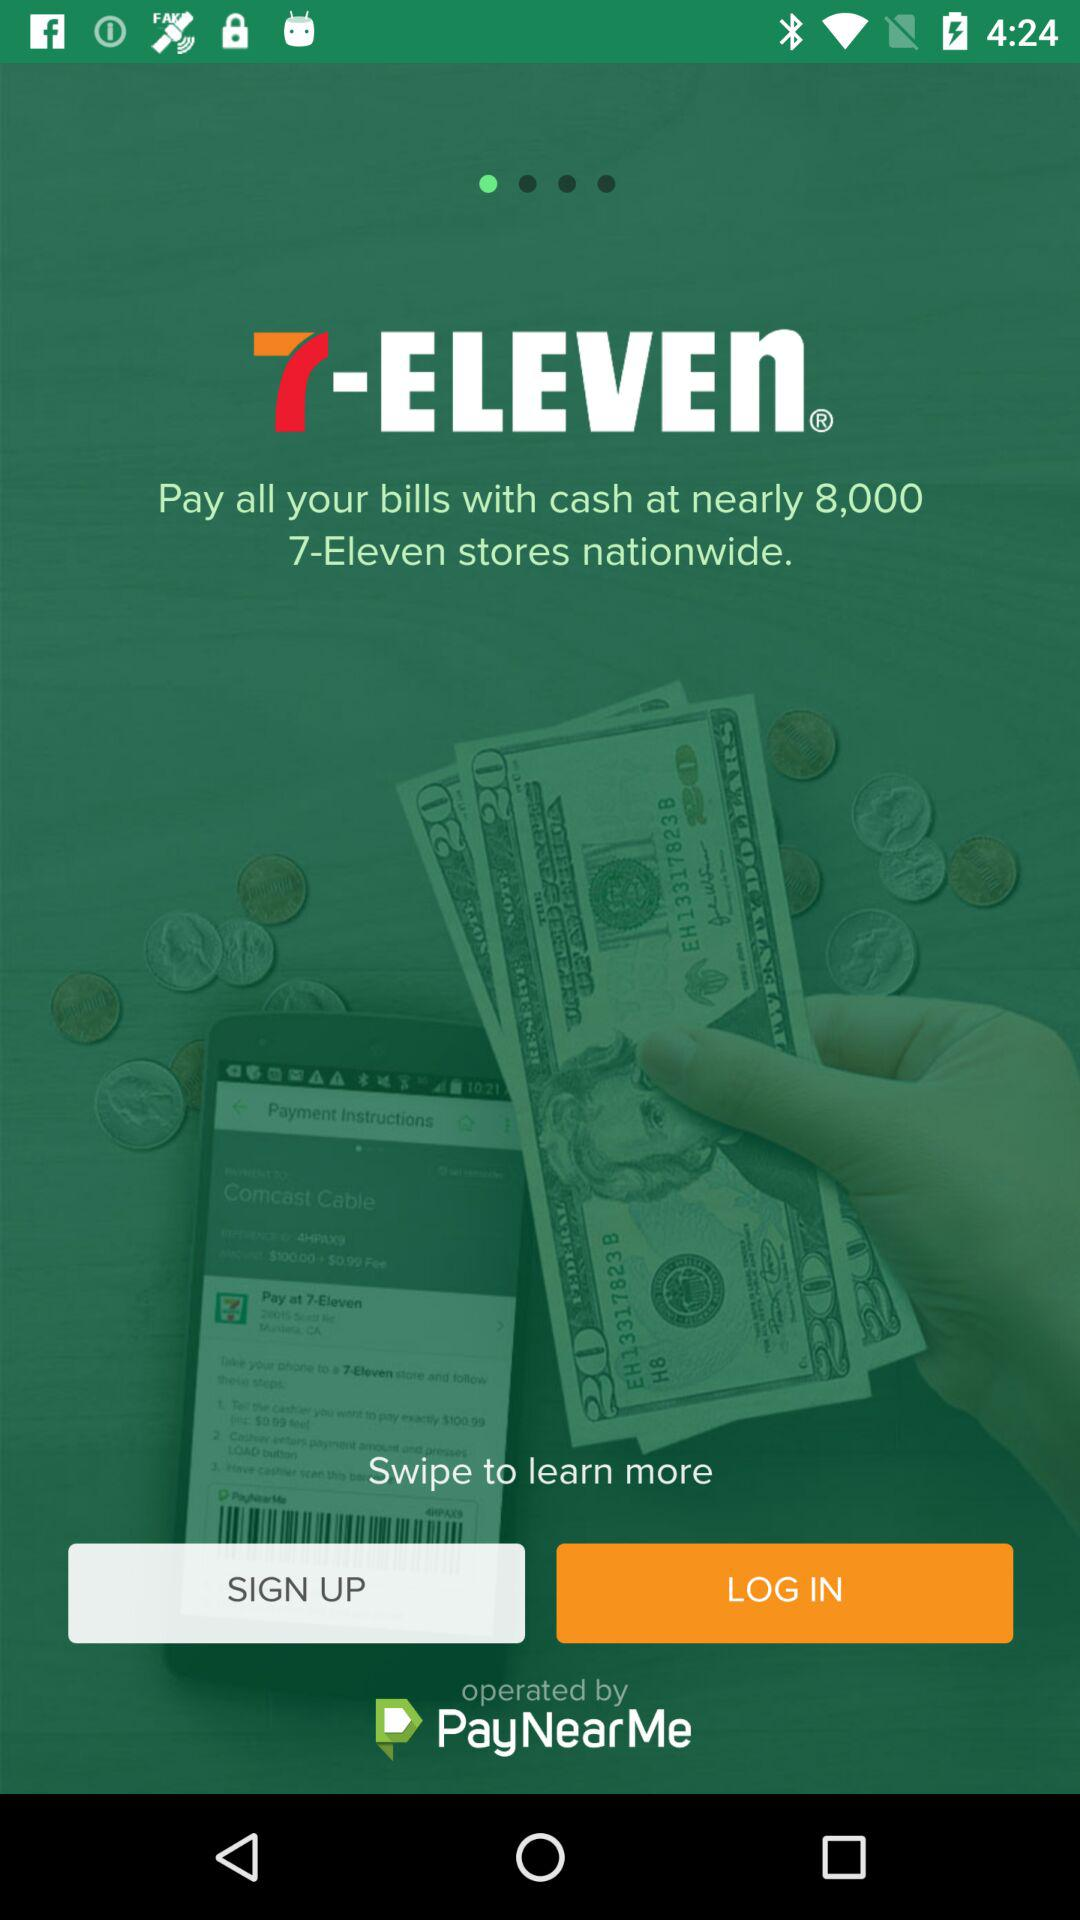What can a user do by swiping? The user can learn more by swiping. 